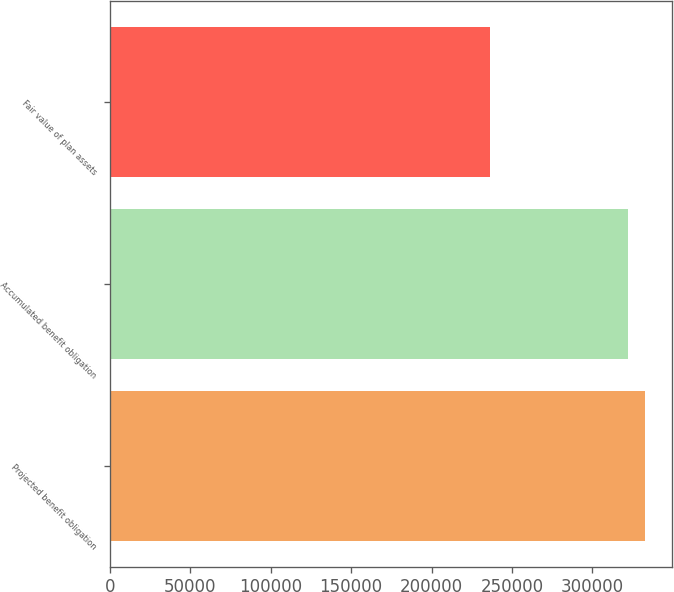<chart> <loc_0><loc_0><loc_500><loc_500><bar_chart><fcel>Projected benefit obligation<fcel>Accumulated benefit obligation<fcel>Fair value of plan assets<nl><fcel>332952<fcel>321963<fcel>236145<nl></chart> 